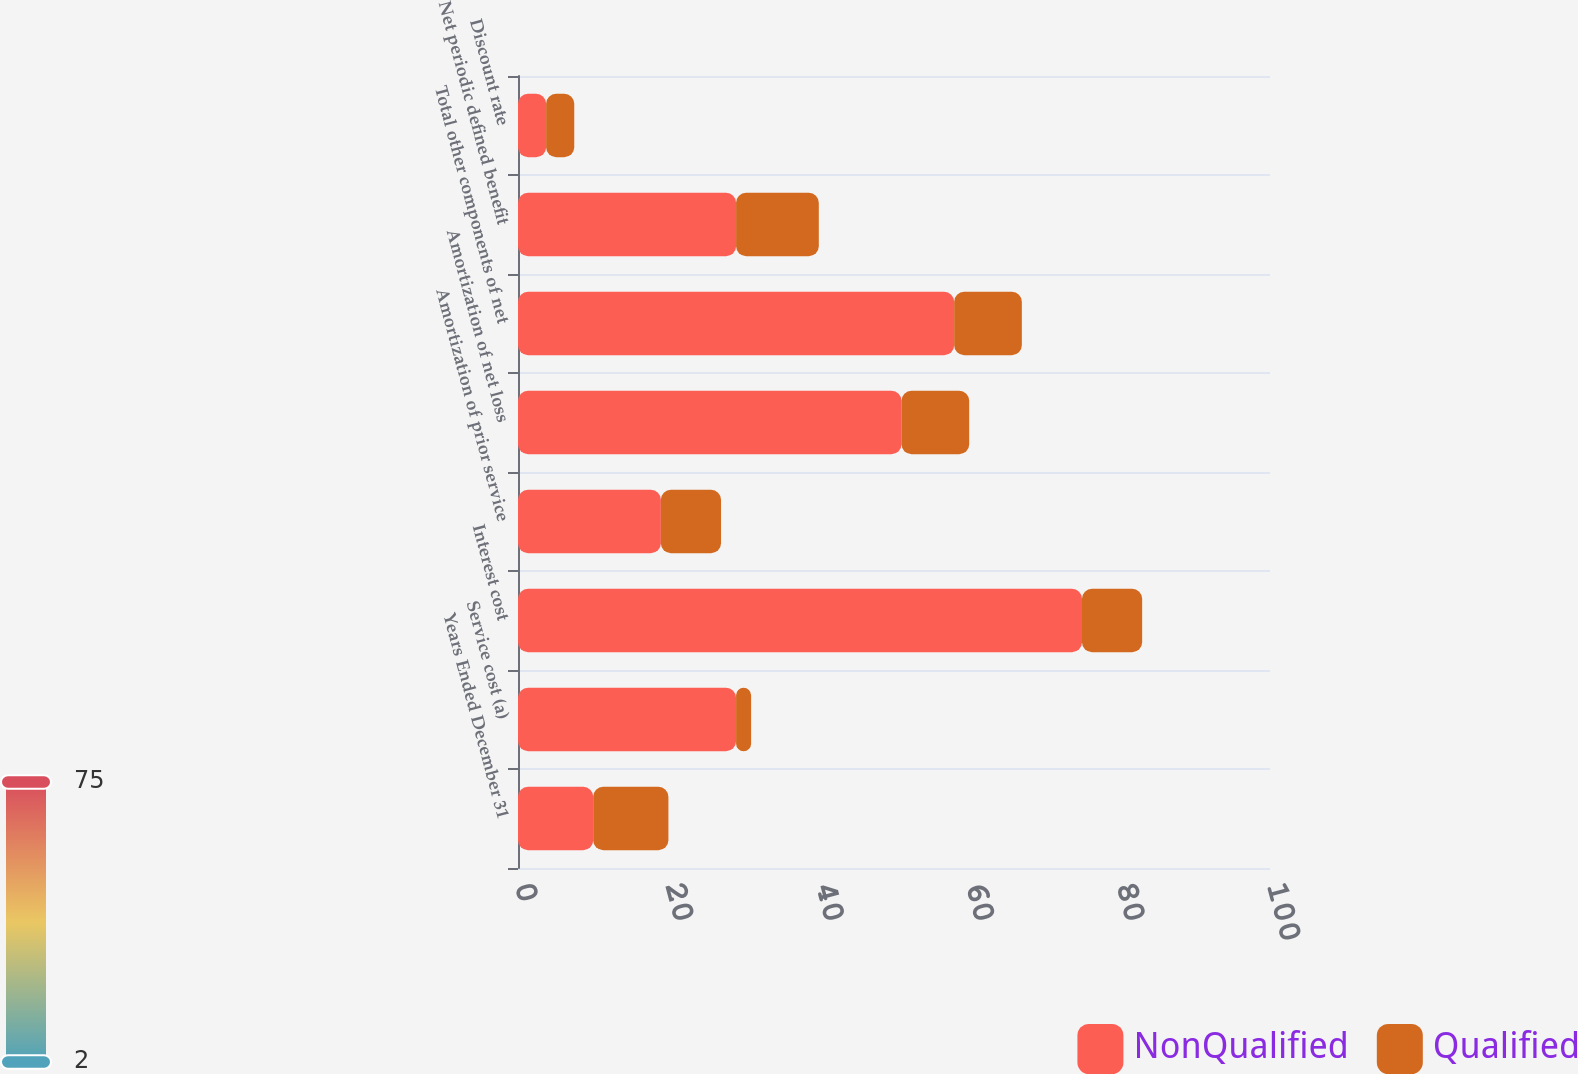Convert chart to OTSL. <chart><loc_0><loc_0><loc_500><loc_500><stacked_bar_chart><ecel><fcel>Years Ended December 31<fcel>Service cost (a)<fcel>Interest cost<fcel>Amortization of prior service<fcel>Amortization of net loss<fcel>Total other components of net<fcel>Net periodic defined benefit<fcel>Discount rate<nl><fcel>NonQualified<fcel>10<fcel>29<fcel>75<fcel>19<fcel>51<fcel>58<fcel>29<fcel>3.74<nl><fcel>Qualified<fcel>10<fcel>2<fcel>8<fcel>8<fcel>9<fcel>9<fcel>11<fcel>3.74<nl></chart> 